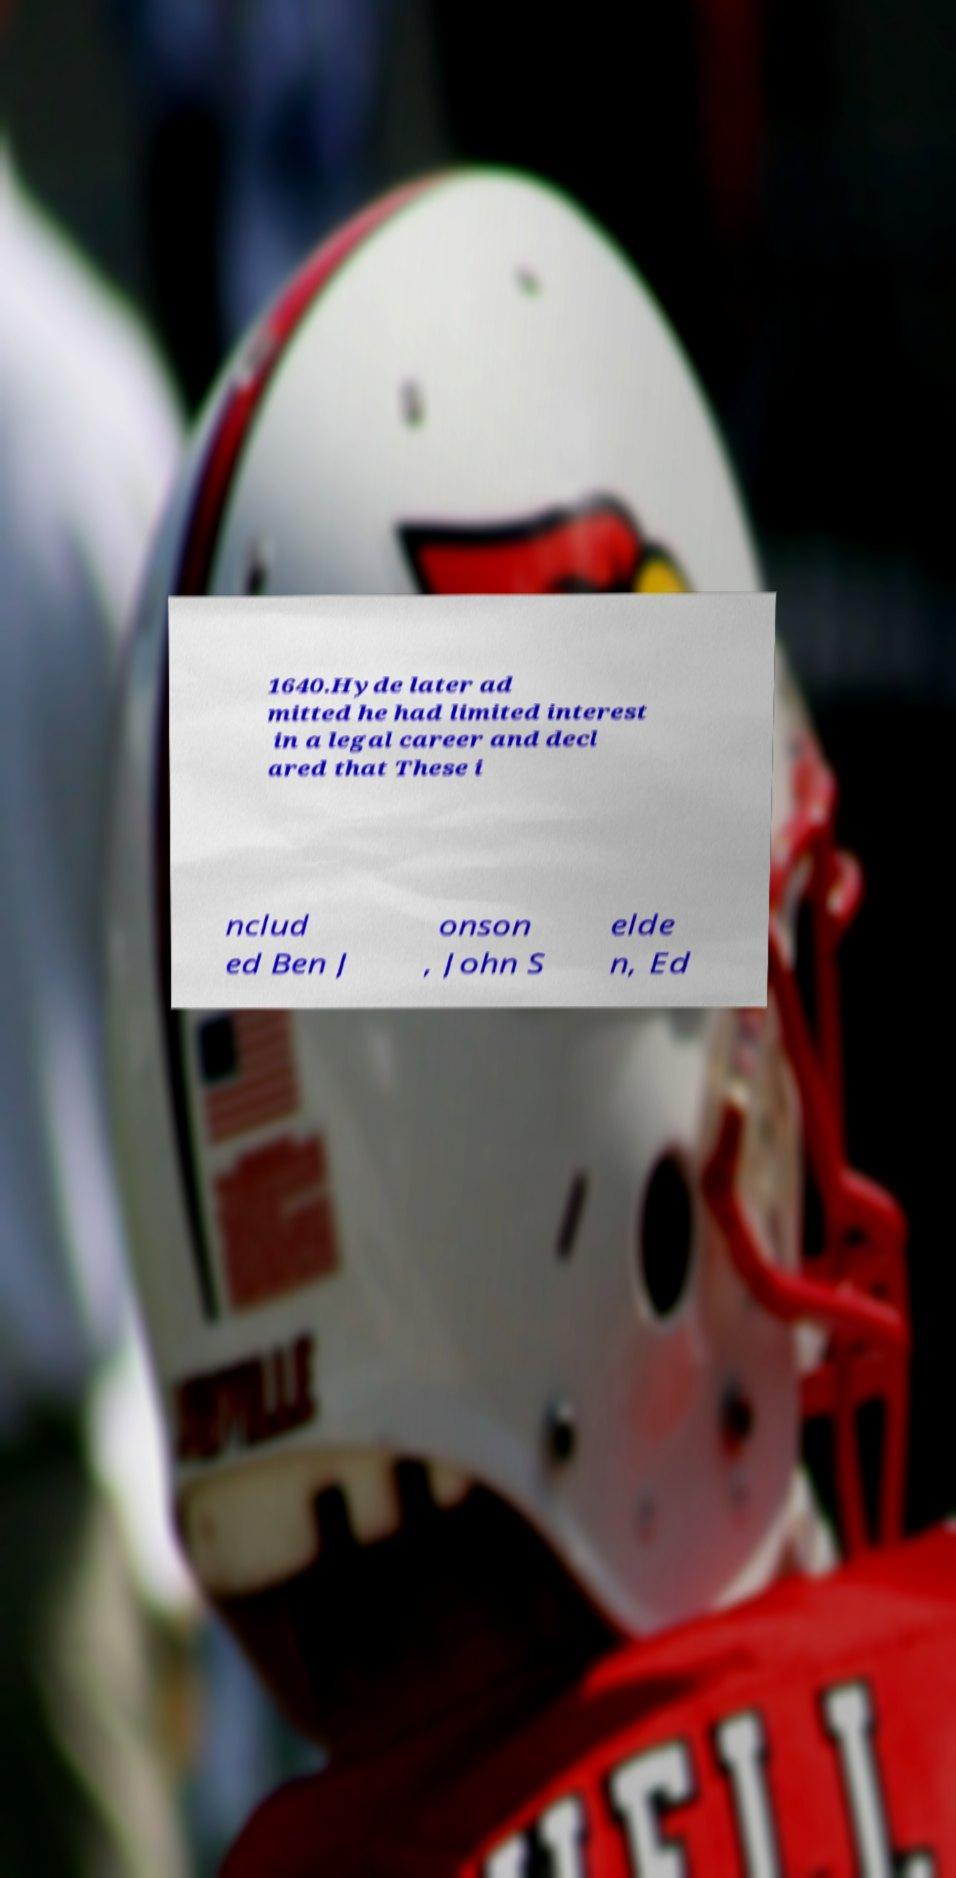What messages or text are displayed in this image? I need them in a readable, typed format. 1640.Hyde later ad mitted he had limited interest in a legal career and decl ared that These i nclud ed Ben J onson , John S elde n, Ed 